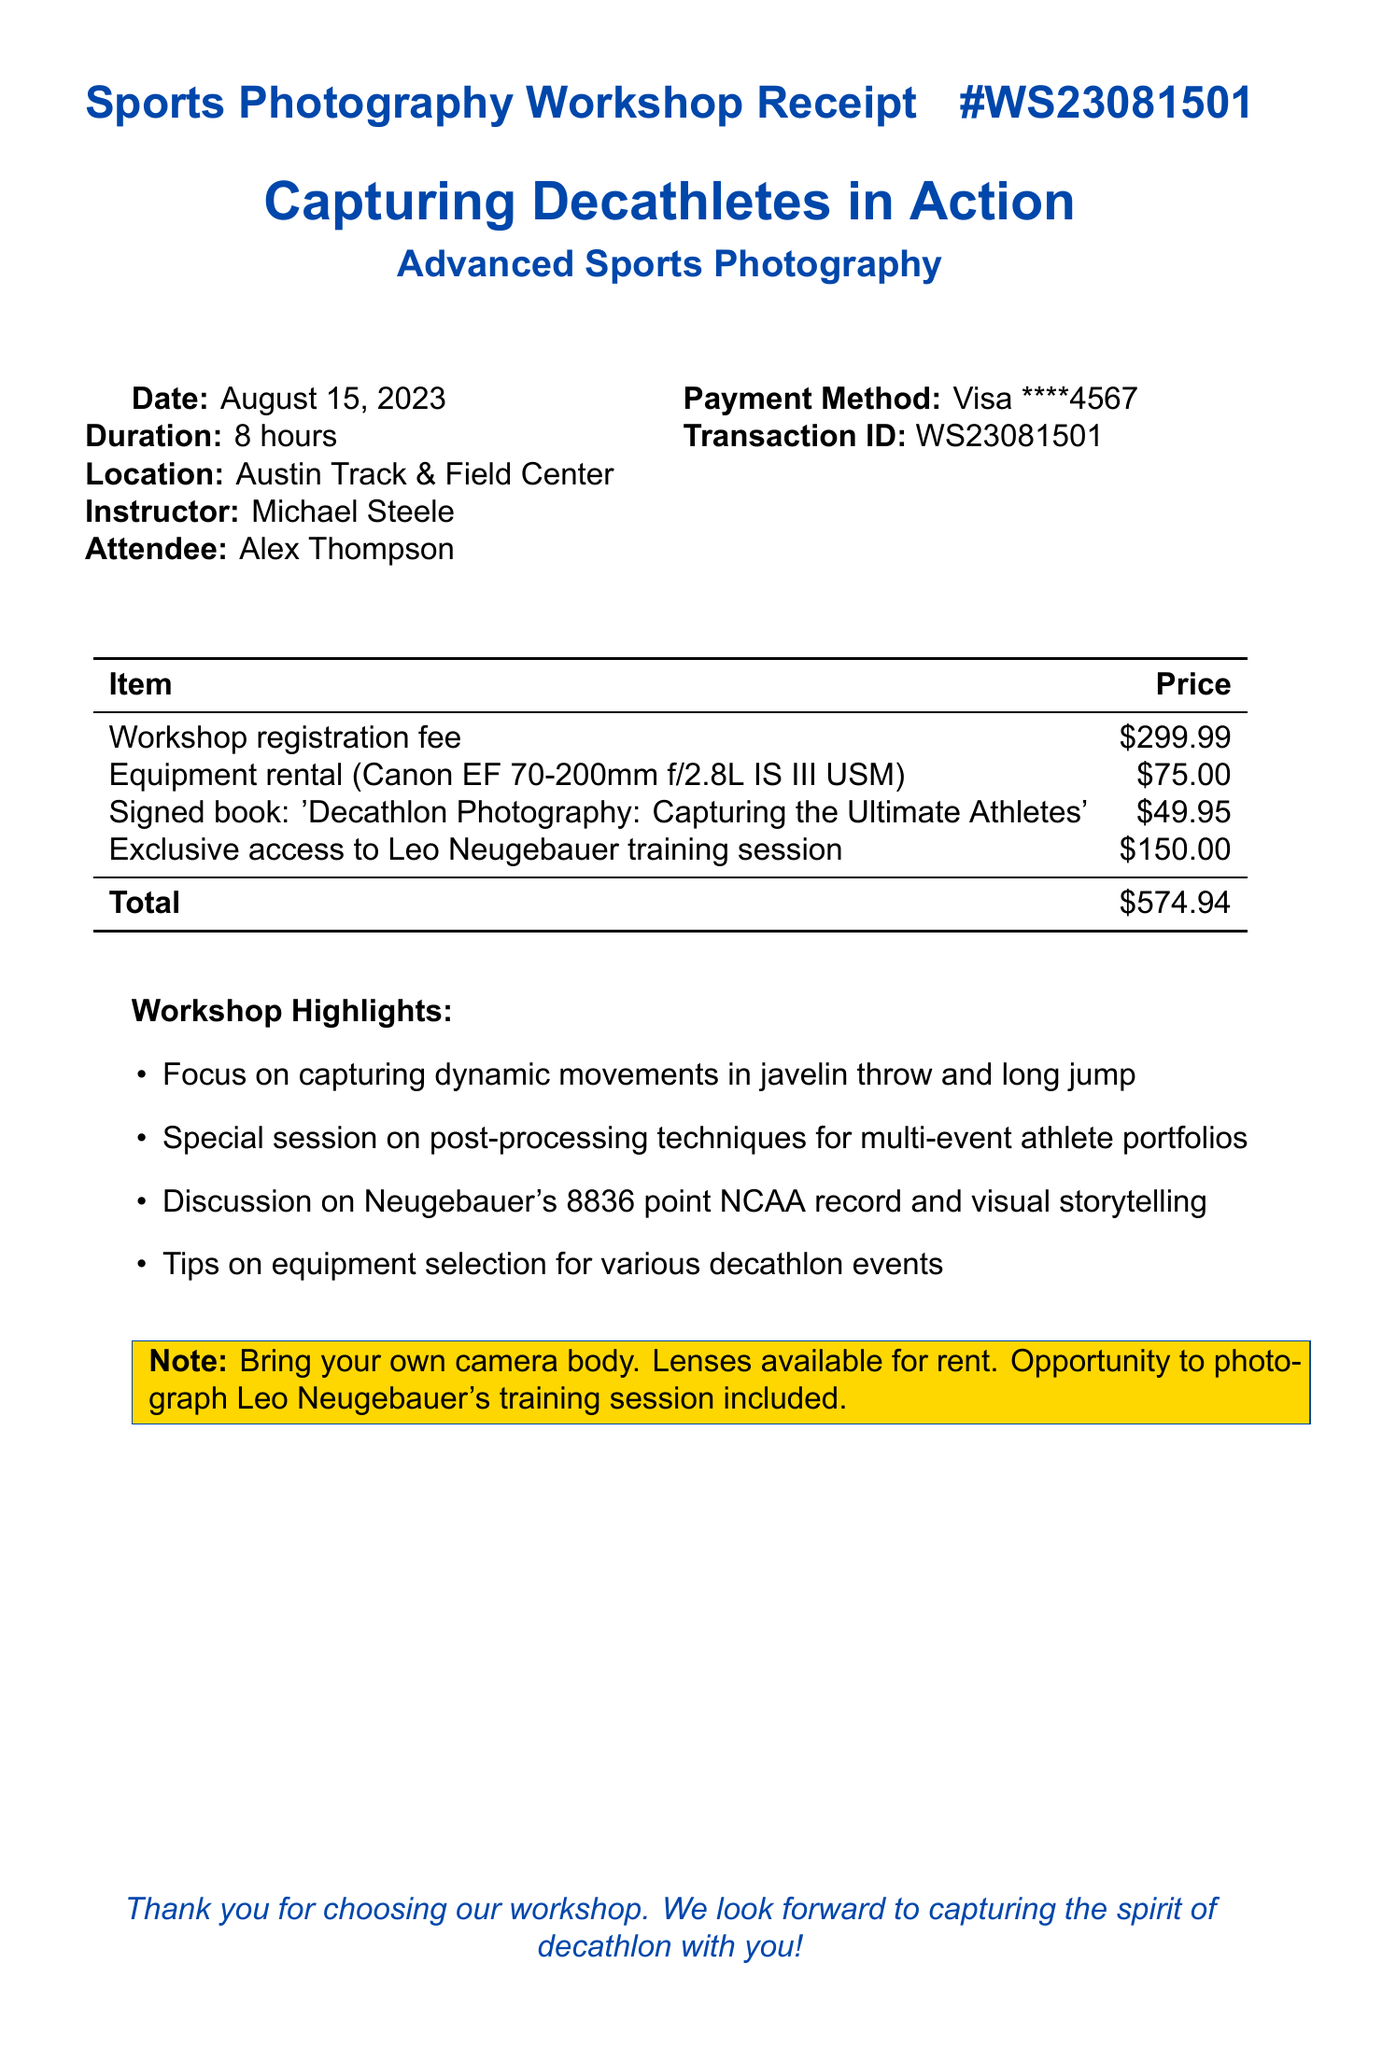What is the workshop name? The workshop name is specified at the top of the document, which is "Capturing Decathletes in Action: Advanced Sports Photography."
Answer: Capturing Decathletes in Action: Advanced Sports Photography Who is the instructor? The instructor's name is listed in the document as Michael Steele.
Answer: Michael Steele What is the date of the workshop? The date is explicitly stated in the document as August 15, 2023.
Answer: August 15, 2023 How much does the signed copy of the book cost? The price for the signed copy of the book is mentioned in the itemized list as $49.95.
Answer: $49.95 What is the total price for the workshop? The total price is calculated and summarized at the bottom of the item list as $574.94.
Answer: $574.94 What special session is included in the workshop? The document mentions a special session on post-processing techniques for multi-event athlete portfolios.
Answer: Post-processing techniques for multi-event athlete portfolios Which athlete's training session can participants access? The document specifically states that participants have exclusive access to Leo Neugebauer's training session.
Answer: Leo Neugebauer What payment method was used? The payment method is stated as Visa, with the last four digits of the card provided.
Answer: Visa What should attendees bring to the workshop? The note section mentions that attendees should bring their own camera body.
Answer: Own camera body 